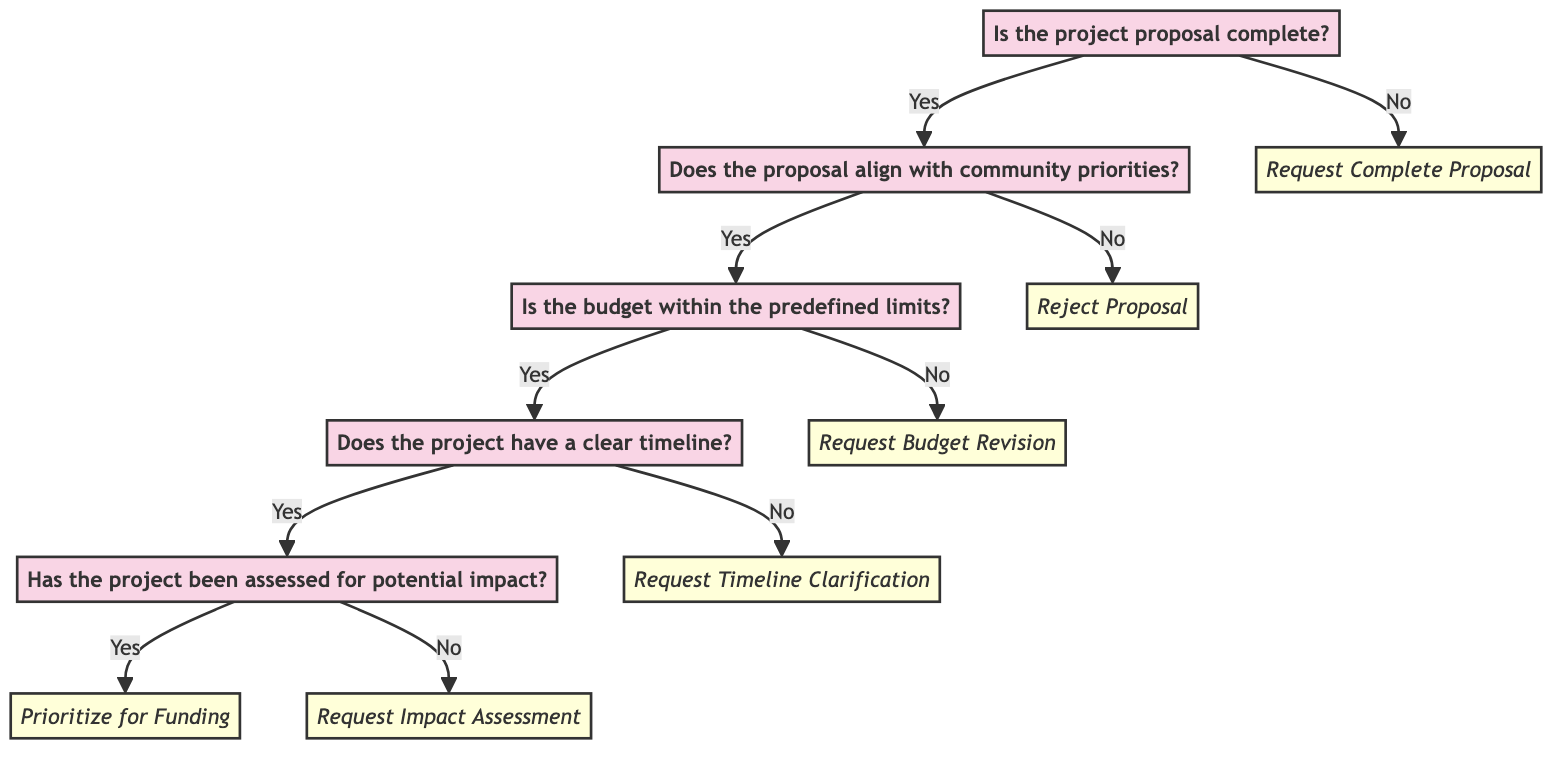What is the first question in the decision tree? The first question in the decision tree is presented as the initial node and asks, "Is the project proposal complete?"
Answer: Is the project proposal complete? How many end nodes are present in the diagram? The end nodes are the final responses in the decision tree that terminate the flow: "Prioritize for Funding," "Request Impact Assessment," "Request Timeline Clarification," "Request Budget Revision," "Reject Proposal," and "Request Complete Proposal." Counting these gives us a total of six end nodes.
Answer: 6 What happens if the proposal is not complete? If the proposal is not complete, the diagram shows that the next step is to "Request Complete Proposal." This indicates that the process cannot continue until this requirement is met.
Answer: Request Complete Proposal If the budget is not within limits, what is the next step? When the budget is determined to not be within limits, the decision tree points directly to "Request Budget Revision," indicating that adjustments are needed before proceeding.
Answer: Request Budget Revision What is the outcome if the proposal aligns with community priorities but lacks a clear timeline? In this case, if the proposal aligns with community priorities yet does not have a clear timeline, the decision tree indicates that the next action will be to "Request Timeline Clarification," requiring more information before making a decision.
Answer: Request Timeline Clarification If the project has been assessed for potential impact, what is the result? According to the flow of the diagram, if the project has been successfully assessed for potential impact, the final outcome of that path leads to "Prioritize for Funding," meaning the project is considered for funding.
Answer: Prioritize for Funding What are the conditions that lead to prioritizing a project for funding? The conditions leading to prioritizing a project for funding include the proposal being complete, aligning with community priorities, the budget being within predefined limits, a clear timeline existing, and a positive assessment of potential impact. Each of these conditions must be met sequentially for the project to be prioritized.
Answer: Complete, aligned, within budget, clear timeline, assessed impact If a project proposal does not align with community priorities, what is the conclusion? The decision tree clearly indicates that if a project proposal does not align with community priorities, the process will conclude with a "Reject Proposal" outcome, meaning the project will not be funded or considered further.
Answer: Reject Proposal 